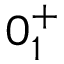<formula> <loc_0><loc_0><loc_500><loc_500>0 _ { 1 } ^ { + }</formula> 